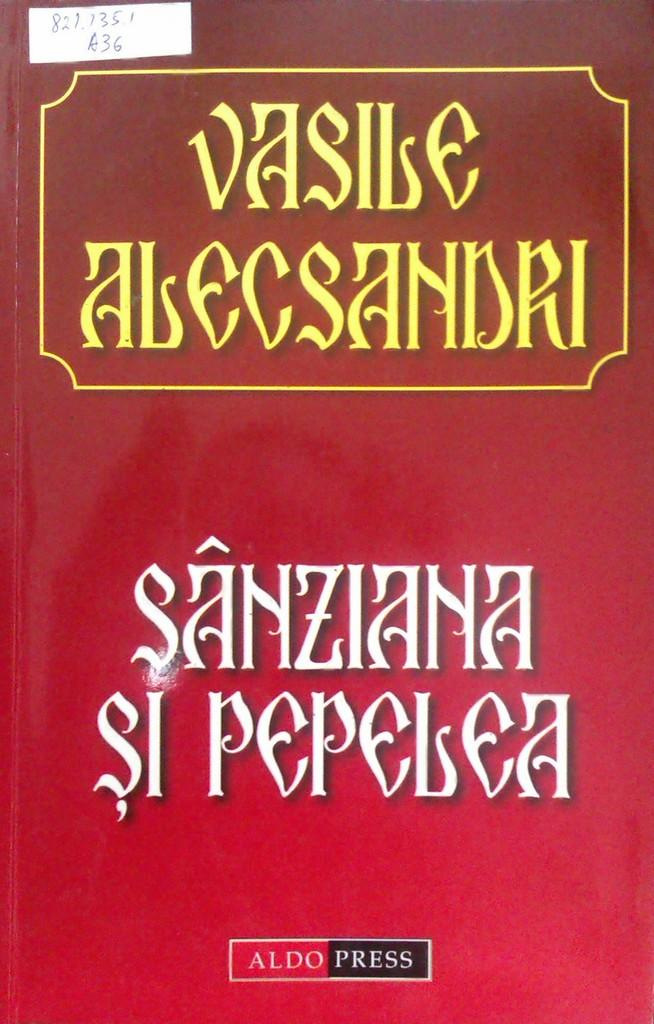<image>
Relay a brief, clear account of the picture shown. A book cover of Vasile Alecsandri published by the AldoPress. 